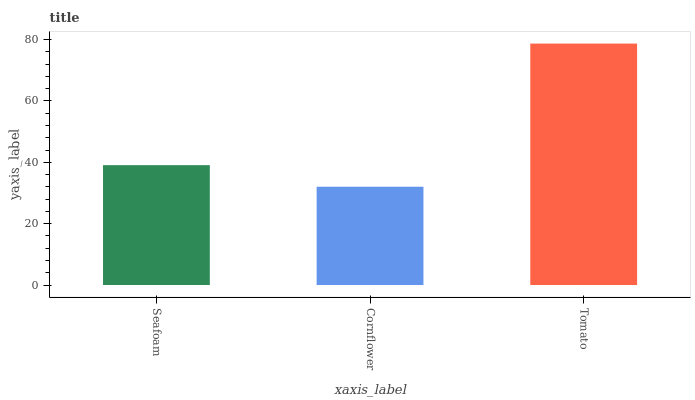Is Cornflower the minimum?
Answer yes or no. Yes. Is Tomato the maximum?
Answer yes or no. Yes. Is Tomato the minimum?
Answer yes or no. No. Is Cornflower the maximum?
Answer yes or no. No. Is Tomato greater than Cornflower?
Answer yes or no. Yes. Is Cornflower less than Tomato?
Answer yes or no. Yes. Is Cornflower greater than Tomato?
Answer yes or no. No. Is Tomato less than Cornflower?
Answer yes or no. No. Is Seafoam the high median?
Answer yes or no. Yes. Is Seafoam the low median?
Answer yes or no. Yes. Is Tomato the high median?
Answer yes or no. No. Is Cornflower the low median?
Answer yes or no. No. 